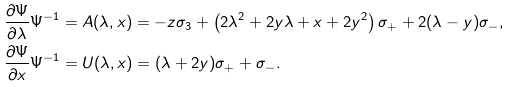Convert formula to latex. <formula><loc_0><loc_0><loc_500><loc_500>& \frac { \partial \Psi } { \partial \lambda } \Psi ^ { - 1 } = A ( \lambda , x ) = - z \sigma _ { 3 } + \left ( 2 \lambda ^ { 2 } + 2 y \lambda + x + 2 y ^ { 2 } \right ) \sigma _ { + } + 2 ( \lambda - y ) \sigma _ { - } , \\ & \frac { \partial \Psi } { \partial x } \Psi ^ { - 1 } = U ( \lambda , x ) = ( \lambda + 2 y ) \sigma _ { + } + \sigma _ { - } .</formula> 